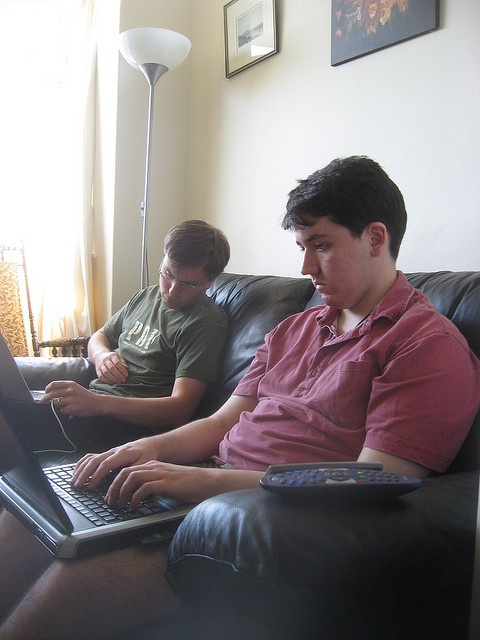Describe the objects in this image and their specific colors. I can see people in white, brown, maroon, and black tones, couch in white, black, and gray tones, people in white, gray, black, and darkgray tones, laptop in white, gray, and black tones, and couch in white, gray, black, and darkgray tones in this image. 